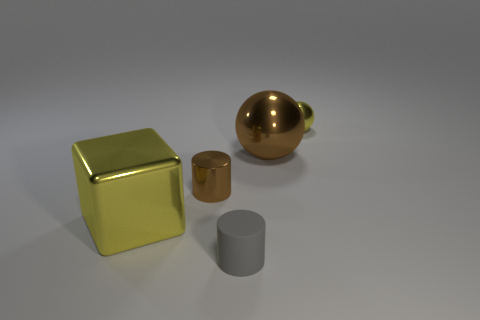Add 3 small rubber things. How many objects exist? 8 Subtract all spheres. How many objects are left? 3 Add 2 small cylinders. How many small cylinders exist? 4 Subtract 1 yellow cubes. How many objects are left? 4 Subtract all tiny yellow things. Subtract all large brown spheres. How many objects are left? 3 Add 5 tiny brown metal cylinders. How many tiny brown metal cylinders are left? 6 